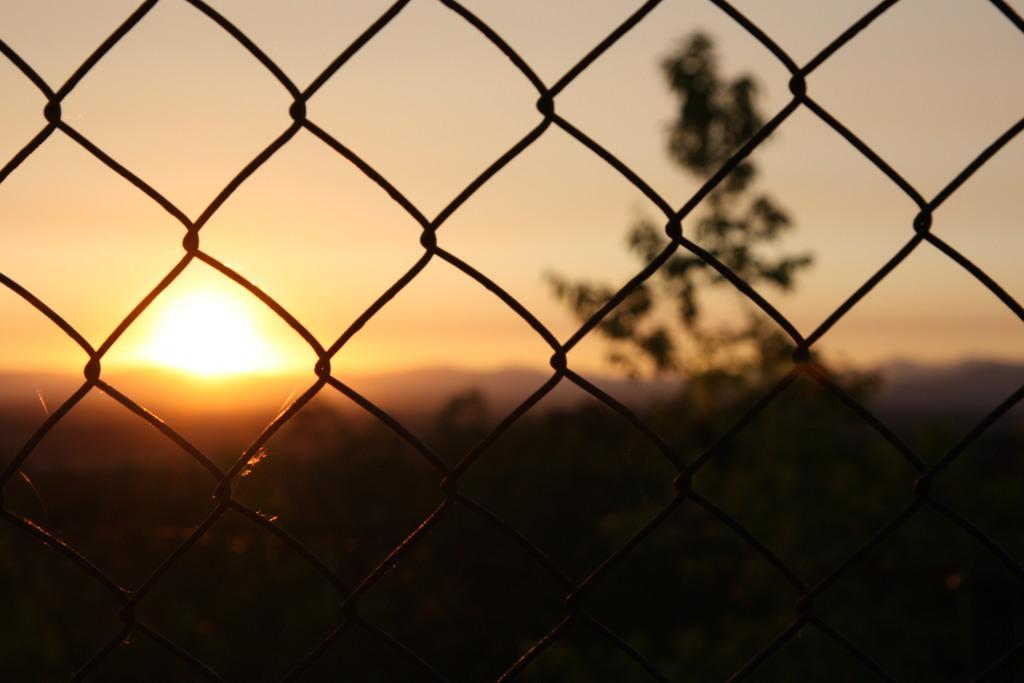What type of structure is present in the image? There is an iron fencing in the image. What can be seen behind the iron fencing? There is a tree behind the iron fencing. What is happening in the sky in the image? There is a sunset visible in the sky. What type of celery is being used to stir the spoon in the image? There is no celery or spoon present in the image. 